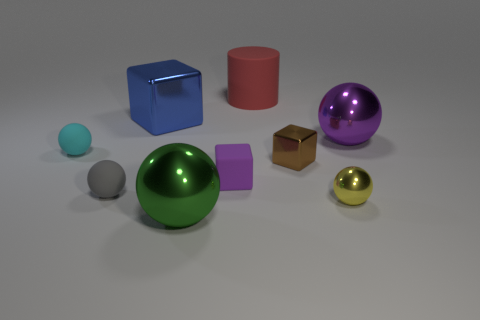There is a matte object that is both behind the purple rubber block and in front of the red cylinder; what is its size?
Give a very brief answer. Small. The large red matte thing that is left of the small ball that is in front of the gray thing is what shape?
Your answer should be compact. Cylinder. Is there anything else that has the same shape as the cyan rubber thing?
Your answer should be very brief. Yes. Are there an equal number of tiny yellow things that are in front of the yellow ball and small yellow rubber spheres?
Your answer should be compact. Yes. Is the color of the cylinder the same as the tiny object that is on the left side of the gray thing?
Keep it short and to the point. No. There is a metal object that is in front of the purple ball and left of the brown object; what is its color?
Ensure brevity in your answer.  Green. What number of big purple metal objects are in front of the large sphere that is in front of the tiny rubber block?
Provide a short and direct response. 0. Is there a small cyan object that has the same shape as the purple shiny thing?
Your answer should be very brief. Yes. There is a large thing in front of the cyan rubber sphere; is it the same shape as the large object on the right side of the red matte cylinder?
Make the answer very short. Yes. What number of things are yellow balls or gray matte objects?
Your answer should be compact. 2. 